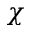Convert formula to latex. <formula><loc_0><loc_0><loc_500><loc_500>\chi</formula> 